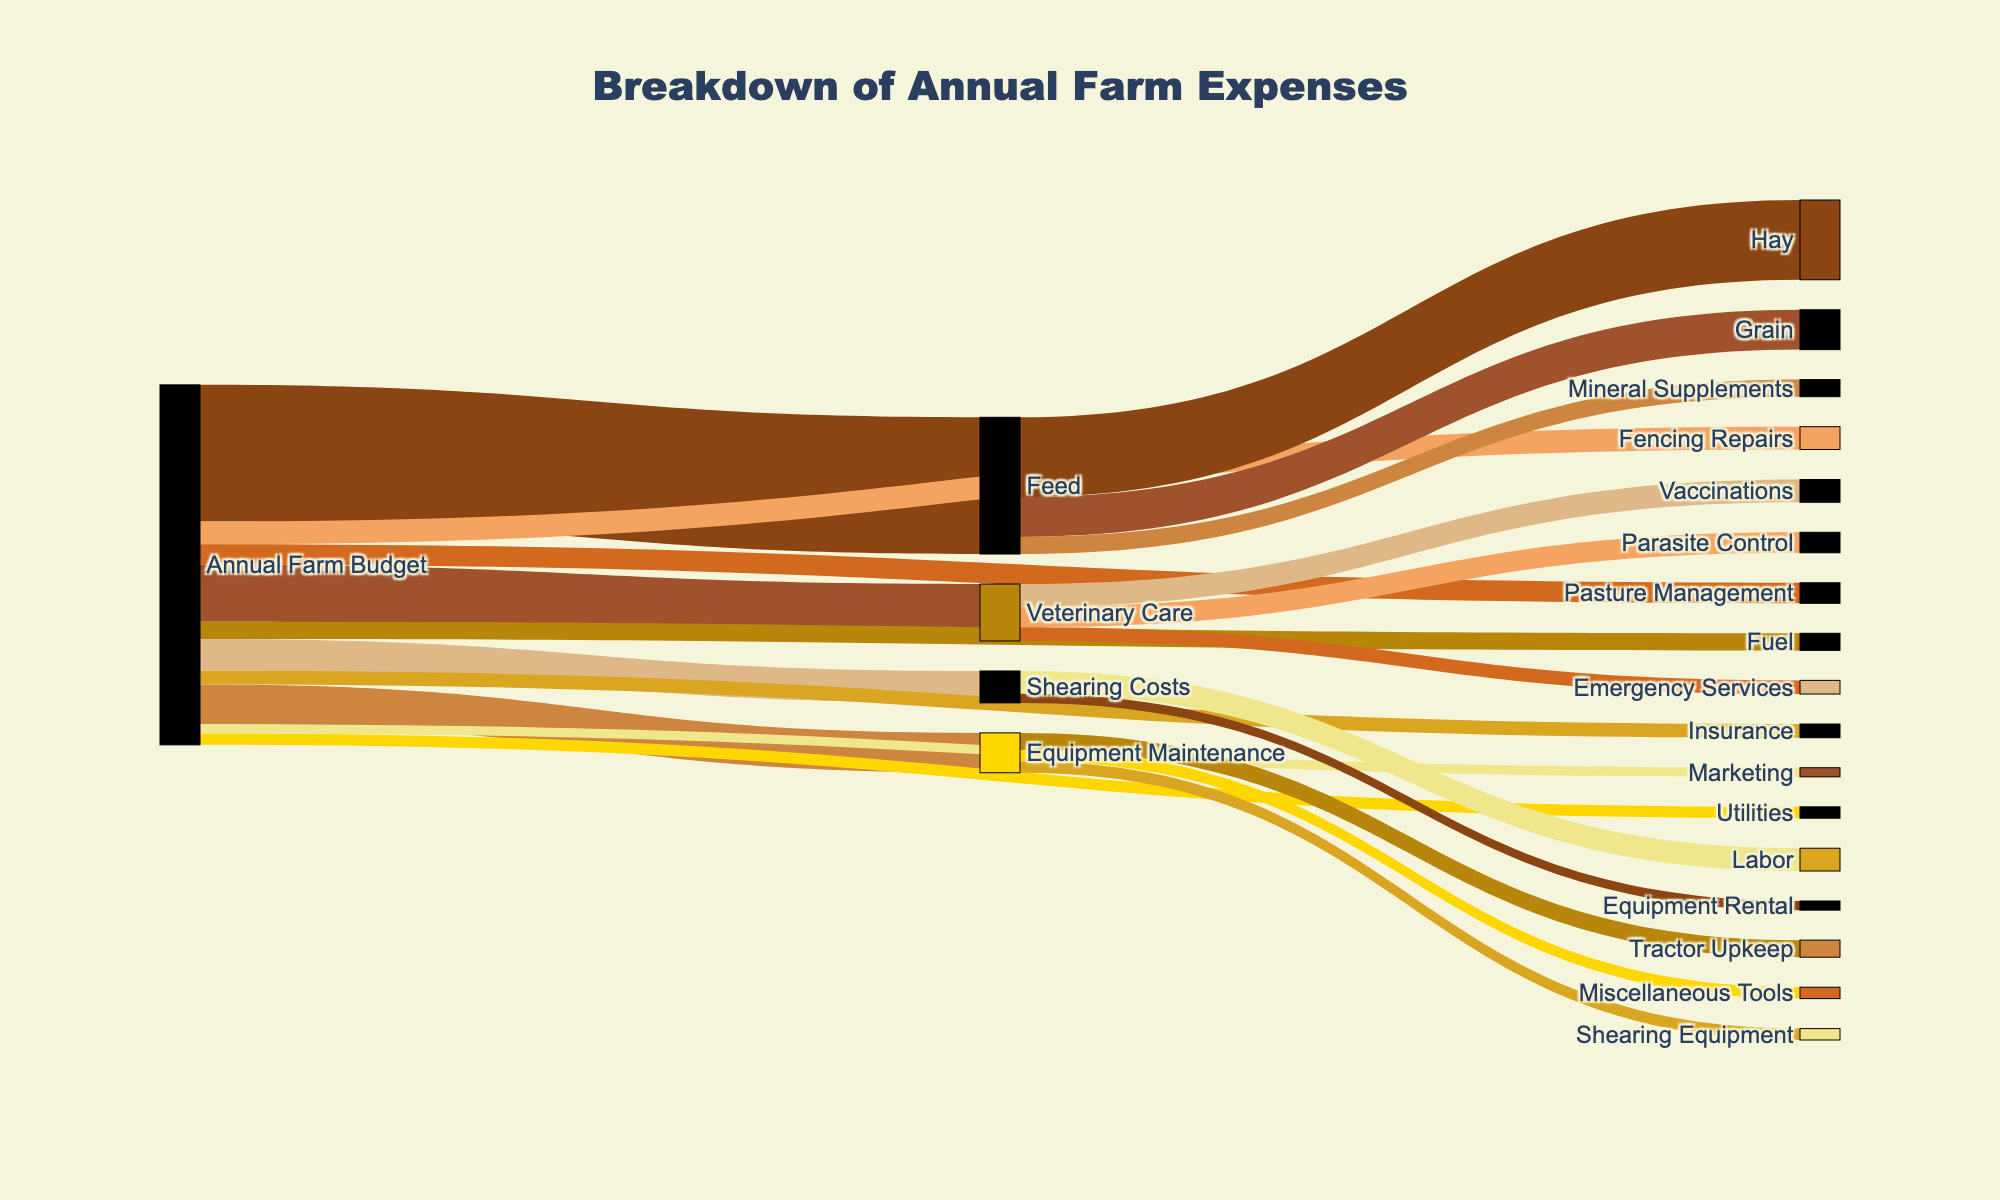What's the largest expense under feed? By looking at the Sankey diagram, check the flows that originate from the "Feed" node and find the one with the highest value.
Answer: Hay What is the smallest category under veterinary care? Look at the flows from the "Veterinary Care" node and identify the one with the smallest value.
Answer: Emergency Services How much is spent on feed and shearing costs together? Add the values of the flows from "Annual Farm Budget" to "Feed" and "Annual Farm Budget" to "Shearing Costs".
Answer: 14800 Which expense category under equipment maintenance has the same value? Check the flows from "Equipment Maintenance" to see if any two are equal.
Answer: Shearing Equipment and Miscellaneous Tools How much does pasture management cost relative to utilities? Compare the flows from "Annual Farm Budget" to "Pasture Management" and "Annual Farm Budget" to "Utilities".
Answer: Pasture Management costs 800 more than Utilities Which category takes up the major portion of the annual farm budget? Identify the flow from "Annual Farm Budget" to a category with the highest value.
Answer: Feed What is the total expense for the farm insurance and marketing? Add the values of the flows from "Annual Farm Budget" to "Insurance" and "Annual Farm Budget" to "Marketing".
Answer: 2000 Which expense category has the highest number of subcategories? Count the number of flows originating from each primary category. The one with the most links has the highest number of subcategories.
Answer: Veterinary Care How much more is spent on hay than on grain? Subtract the value of the flow from "Feed" to "Grain" from the flow from "Feed" to "Hay".
Answer: 3500 Which subcategory under equipment maintenance contributes the least to the total expense? Identify the smallest flow value under "Equipment Maintenance".
Answer: Shearing Equipment and Miscellaneous Tools 